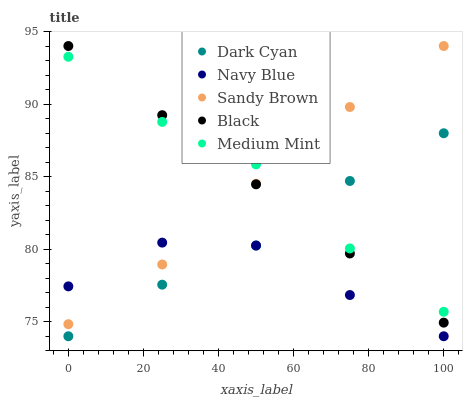Does Navy Blue have the minimum area under the curve?
Answer yes or no. Yes. Does Medium Mint have the maximum area under the curve?
Answer yes or no. Yes. Does Sandy Brown have the minimum area under the curve?
Answer yes or no. No. Does Sandy Brown have the maximum area under the curve?
Answer yes or no. No. Is Black the smoothest?
Answer yes or no. Yes. Is Navy Blue the roughest?
Answer yes or no. Yes. Is Sandy Brown the smoothest?
Answer yes or no. No. Is Sandy Brown the roughest?
Answer yes or no. No. Does Dark Cyan have the lowest value?
Answer yes or no. Yes. Does Sandy Brown have the lowest value?
Answer yes or no. No. Does Black have the highest value?
Answer yes or no. Yes. Does Navy Blue have the highest value?
Answer yes or no. No. Is Navy Blue less than Medium Mint?
Answer yes or no. Yes. Is Medium Mint greater than Navy Blue?
Answer yes or no. Yes. Does Black intersect Dark Cyan?
Answer yes or no. Yes. Is Black less than Dark Cyan?
Answer yes or no. No. Is Black greater than Dark Cyan?
Answer yes or no. No. Does Navy Blue intersect Medium Mint?
Answer yes or no. No. 